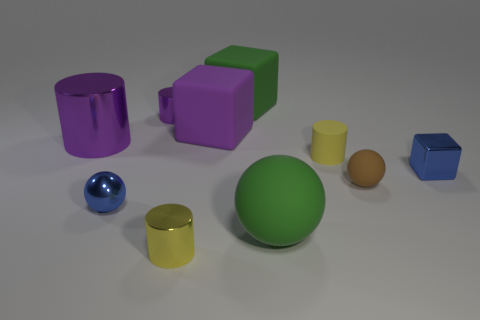The large rubber thing in front of the large shiny thing is what color?
Your answer should be very brief. Green. The blue thing that is right of the large green rubber thing in front of the matte cylinder is what shape?
Keep it short and to the point. Cube. Is the large green sphere made of the same material as the yellow cylinder that is behind the brown sphere?
Ensure brevity in your answer.  Yes. There is a metal object that is the same color as the tiny block; what is its shape?
Provide a succinct answer. Sphere. What number of blue cubes have the same size as the metal sphere?
Offer a very short reply. 1. Are there fewer metallic cubes that are in front of the tiny blue metallic cube than small purple objects?
Keep it short and to the point. Yes. There is a green rubber sphere; what number of small brown matte objects are right of it?
Provide a succinct answer. 1. How big is the purple thing that is left of the blue sphere to the left of the small cylinder behind the large purple cylinder?
Offer a terse response. Large. Does the yellow rubber object have the same shape as the large green thing that is in front of the big purple rubber cube?
Make the answer very short. No. There is a purple thing that is made of the same material as the large green block; what size is it?
Provide a short and direct response. Large. 